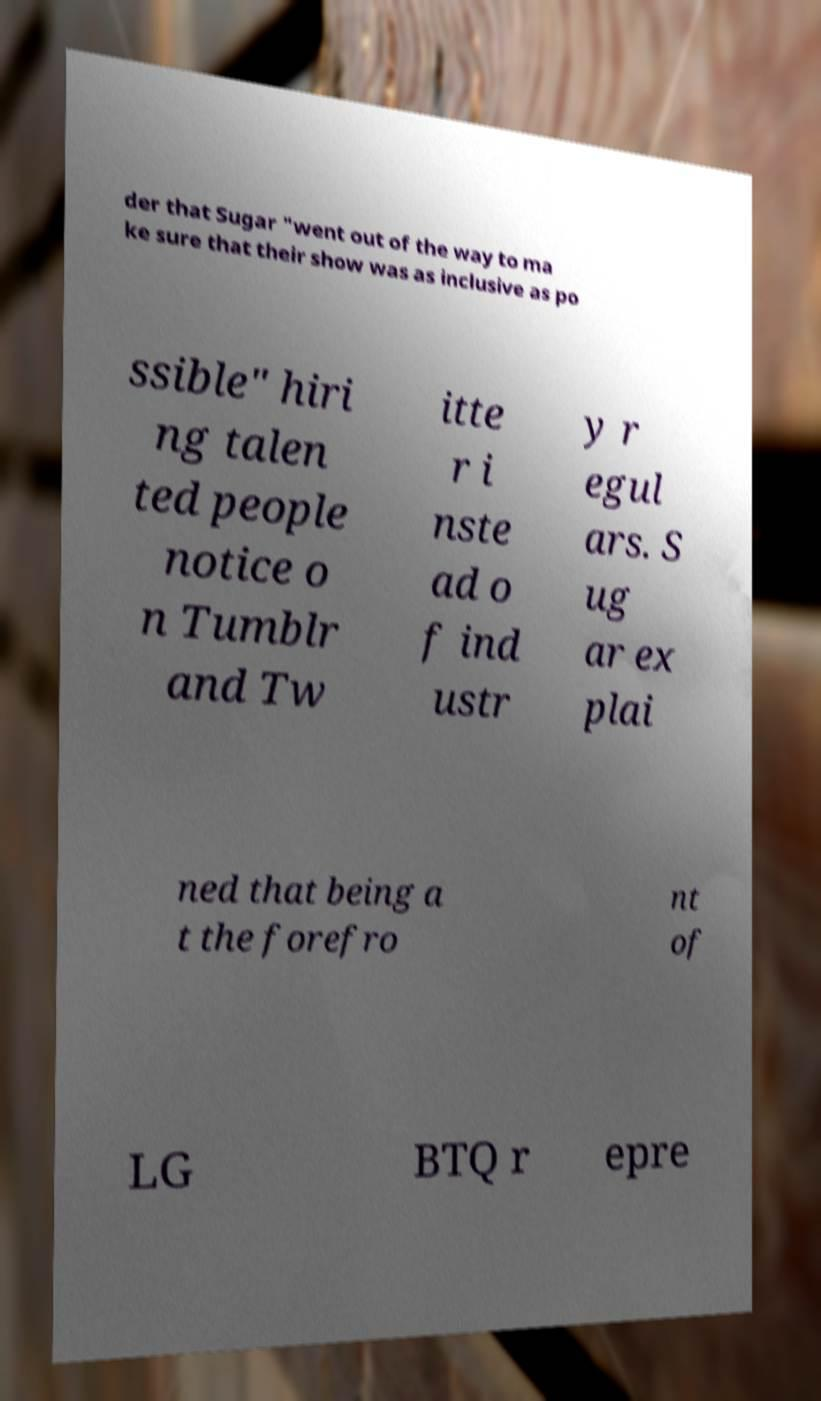Can you accurately transcribe the text from the provided image for me? der that Sugar "went out of the way to ma ke sure that their show was as inclusive as po ssible" hiri ng talen ted people notice o n Tumblr and Tw itte r i nste ad o f ind ustr y r egul ars. S ug ar ex plai ned that being a t the forefro nt of LG BTQ r epre 